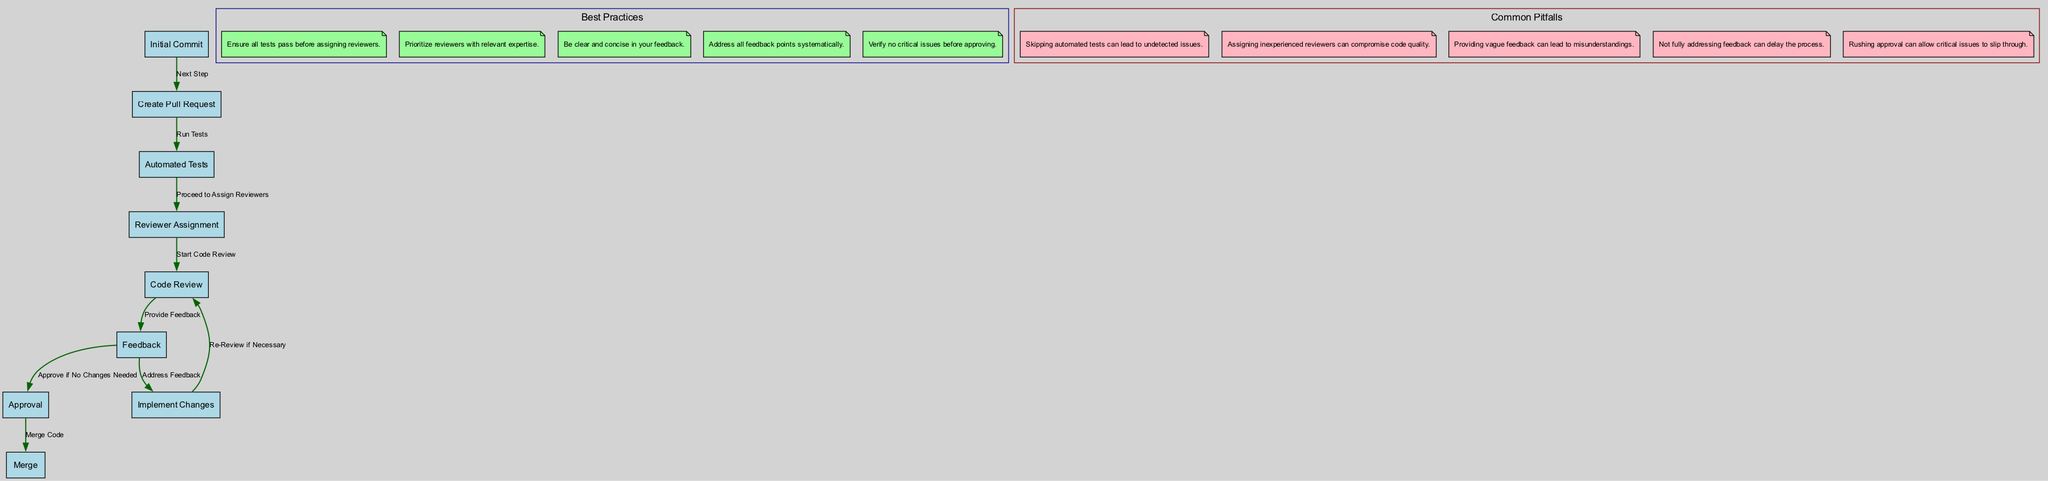What is the first step in the code review process? The first step is labeled "Initial Commit," where the developer pushes new code to the repository. This is indicated prominently as the starting node in the diagram.
Answer: Initial Commit How many main steps are there in the code review process workflow? By counting the nodes in the diagram that represent the main steps (from "Initial Commit" to "Merge"), we find there are nine distinct steps.
Answer: Nine What follows after creating a pull request? After the "Create Pull Request" step, the next step indicated in the diagram is "Automated Tests," where automated tests are run to catch basic errors.
Answer: Automated Tests Which step involves assigning reviewers? The step where reviewers are assigned is labeled "Reviewer Assignment," where reviewers are chosen based on their expertise in the code base.
Answer: Reviewer Assignment What best practice is related to automated tests? The best practice linked to automated tests states, "Ensure all tests pass before assigning reviewers." This is represented in the best practices section of the diagram.
Answer: Ensure all tests pass before assigning reviewers Why is vague feedback a common pitfall? Vague feedback can lead to misunderstandings, as it lacks the clarity needed for the developer to properly address issues. In the diagram, this pitfall is highlighted to warn reviewers against it.
Answer: Misunderstandings Which step follows after feedback is provided? Following the "Feedback" step, the next step is "Implement Changes," where the developer addresses feedback and updates the pull request accordingly.
Answer: Implement Changes How does the code proceed to merging? Code proceeds to "Merge" after it has been "Approved." This linkage in the diagram illustrates the flow from approval to the merging of approved code into the main branch.
Answer: Approved What is a common pitfall regarding reviewer assignments? A common pitfall related to reviewer assignments is that assigning inexperienced reviewers can compromise code quality, as highlighted in the common pitfalls section of the diagram.
Answer: Inexperienced reviewers 